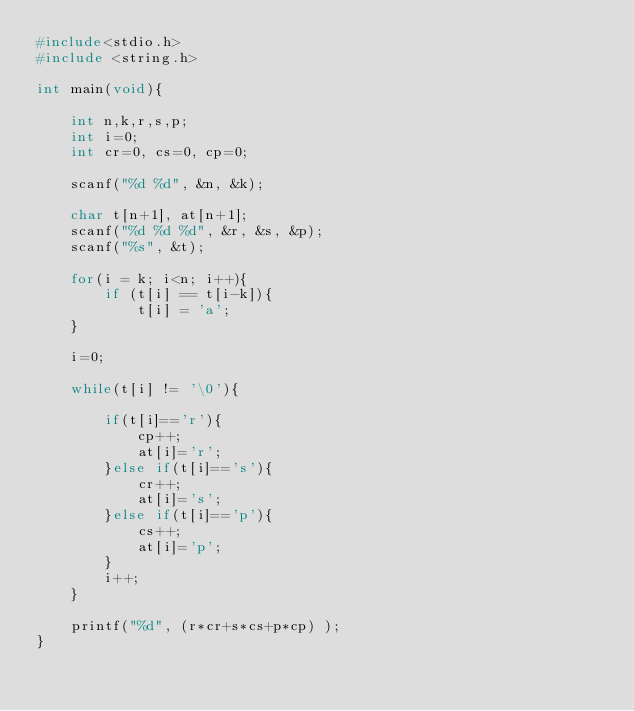Convert code to text. <code><loc_0><loc_0><loc_500><loc_500><_C_>#include<stdio.h>
#include <string.h>

int main(void){

    int n,k,r,s,p;
    int i=0;
    int cr=0, cs=0, cp=0;

    scanf("%d %d", &n, &k);
    
    char t[n+1], at[n+1];
    scanf("%d %d %d", &r, &s, &p);
    scanf("%s", &t);

    for(i = k; i<n; i++){
        if (t[i] == t[i-k]){
            t[i] = 'a';   
    }

    i=0;

    while(t[i] != '\0'){

        if(t[i]=='r'){
            cp++;
            at[i]='r';
        }else if(t[i]=='s'){
            cr++;
            at[i]='s';
        }else if(t[i]=='p'){
            cs++;
            at[i]='p';
        }
        i++;
    }

    printf("%d", (r*cr+s*cs+p*cp) );
}</code> 